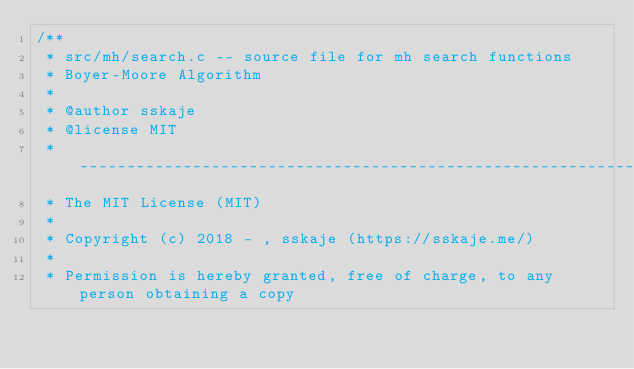<code> <loc_0><loc_0><loc_500><loc_500><_C_>/**
 * src/mh/search.c -- source file for mh search functions
 * Boyer-Moore Algorithm
 *
 * @author sskaje
 * @license MIT
 * ------------------------------------------------------------------------
 * The MIT License (MIT)
 *
 * Copyright (c) 2018 - , sskaje (https://sskaje.me/)
 *
 * Permission is hereby granted, free of charge, to any person obtaining a copy</code> 